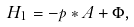<formula> <loc_0><loc_0><loc_500><loc_500>H _ { 1 } = - { p } * { A } + \Phi ,</formula> 